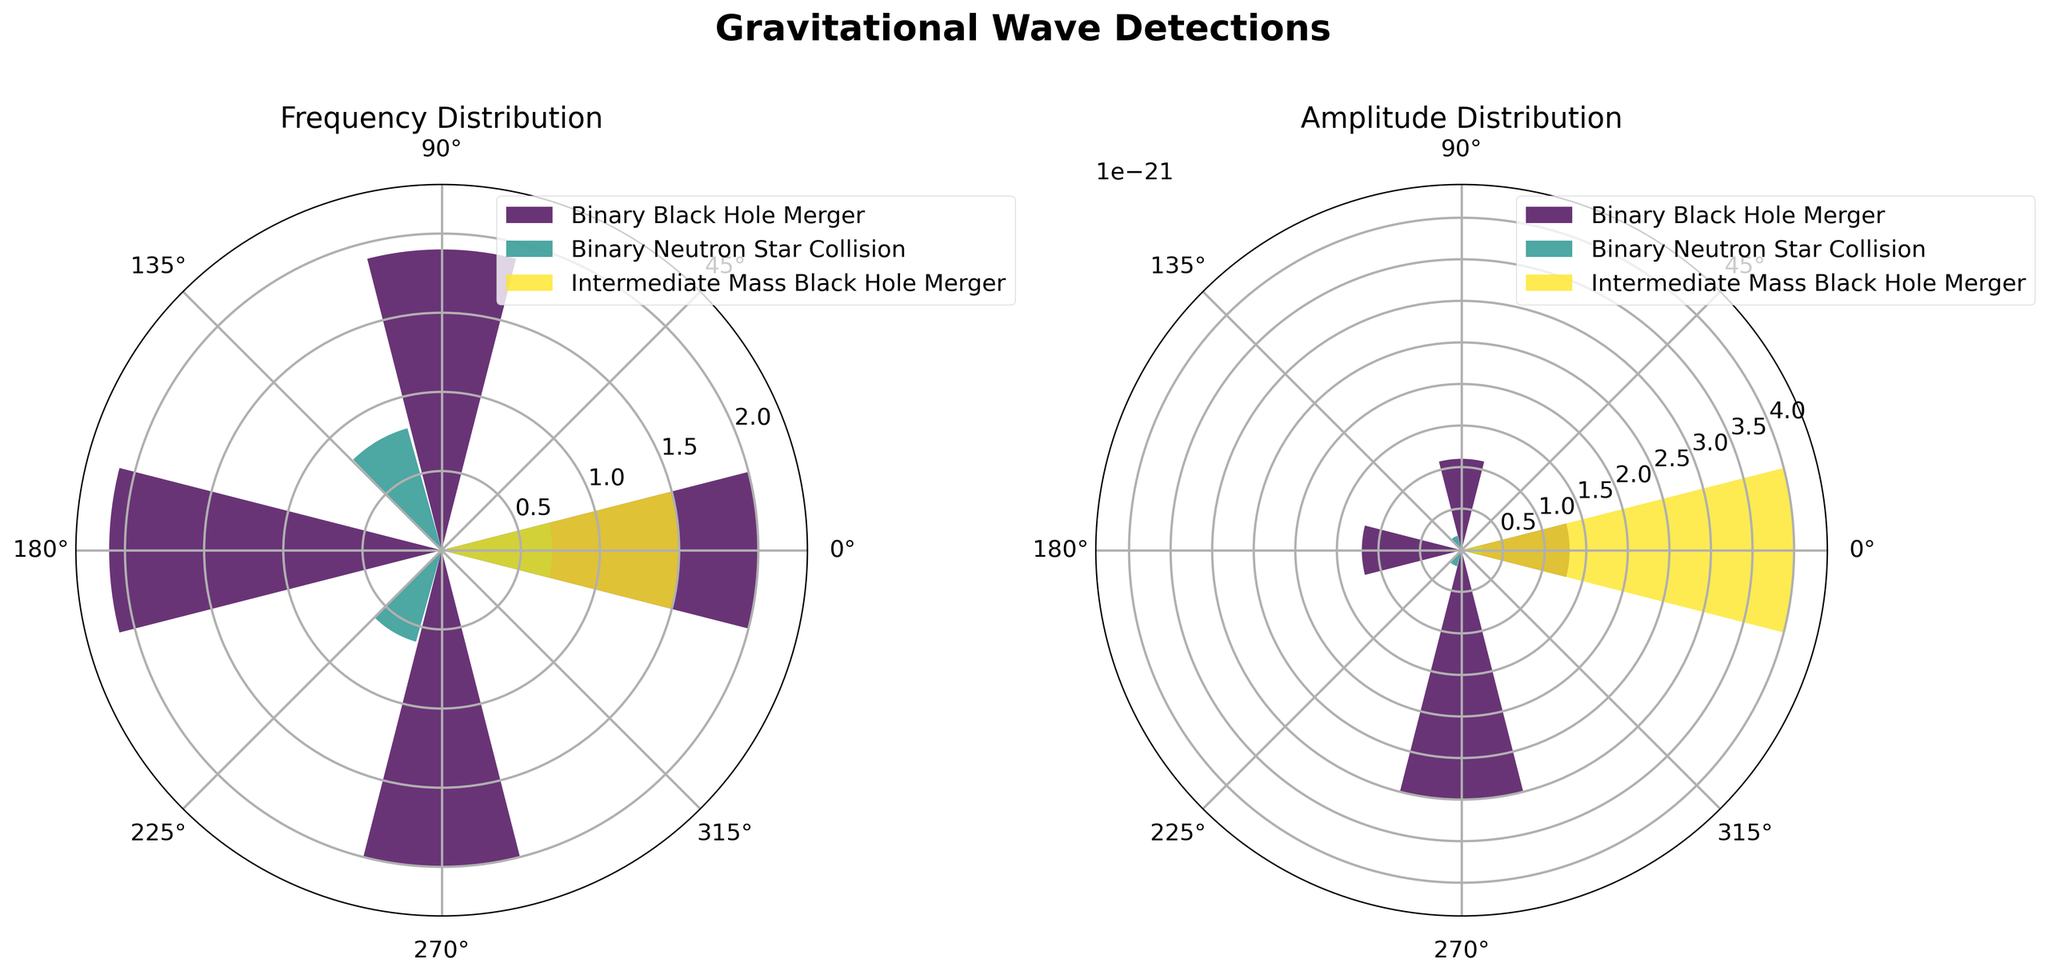How many types of sources are represented in the plots? The legend of the plots lists the unique source types.
Answer: 3 Which type of event has the highest frequency value in the plots? By inspecting the radial bars in the "Frequency Distribution" plot, the largest bar corresponds to the "Binary Black Hole Merger" type.
Answer: Binary Black Hole Merger What is the frequency value for the "Intermediate Mass Black Hole Merger" event? Locate the "Intermediate Mass Black Hole Merger" label in the "Frequency Distribution" plot and find the corresponding bar length.
Answer: 1.5 Compare the amplitude of the "Binary Neutron Star Collision" events. Which one has the highest amplitude? Look at the amplitude values in the "Amplitude Distribution" plot for all "Binary Neutron Star Collision" events. The tallest bar represents the highest amplitude.
Answer: GW170817 What is the average amplitude of the "Binary Black Hole Merger" events? Sum the amplitudes of all "Binary Black Hole Merger" events (1.3e-21 + 1.1e-21 + 1.2e-21 + 3.0e-21) and divide by the number of events.
Answer: 1.65e-21 Which type of event exhibits the most variability in frequency? Compare the spread of the frequency values in the "Frequency Distribution" plot for each type. The type with the widest range depicts the most variability.
Answer: Binary Black Hole Merger How does the highest amplitude of a "Binary Neutron Star Collision" compare to the lowest amplitude of a "Binary Black Hole Merger"? Reference the "Amplitude Distribution" plot to identify the highest and lowest amplitudes for the two respective event types.
Answer: 2.5e-22 is smaller than 1.1e-21 What's the sum of the frequencies for the "Binary Neutron Star Collision" events? Sum the frequencies for all "Binary Neutron Star Collision" events (0.7 + 0.8 + 0.6).
Answer: 2.1 What is the combined amplitude of all "Intermediate Mass Black Hole Merger" and "Binary Black Hole Merger" events? Add the amplitudes (4.0e-21 for "Intermediate Mass Black Hole Merger" + 1.3e-21 + 1.1e-21 + 1.2e-21 + 3.0e-21 for "Binary Black Hole Merger").
Answer: 10.6e-21 In the "Amplitude Distribution" plot, which event stands out with the highest amplitude? Check the heights of all bars in the "Amplitude Distribution" plot and identify the highest one.
Answer: GW190521 